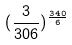<formula> <loc_0><loc_0><loc_500><loc_500>( \frac { 3 } { 3 0 6 } ) ^ { \frac { 3 4 0 } { 6 } }</formula> 